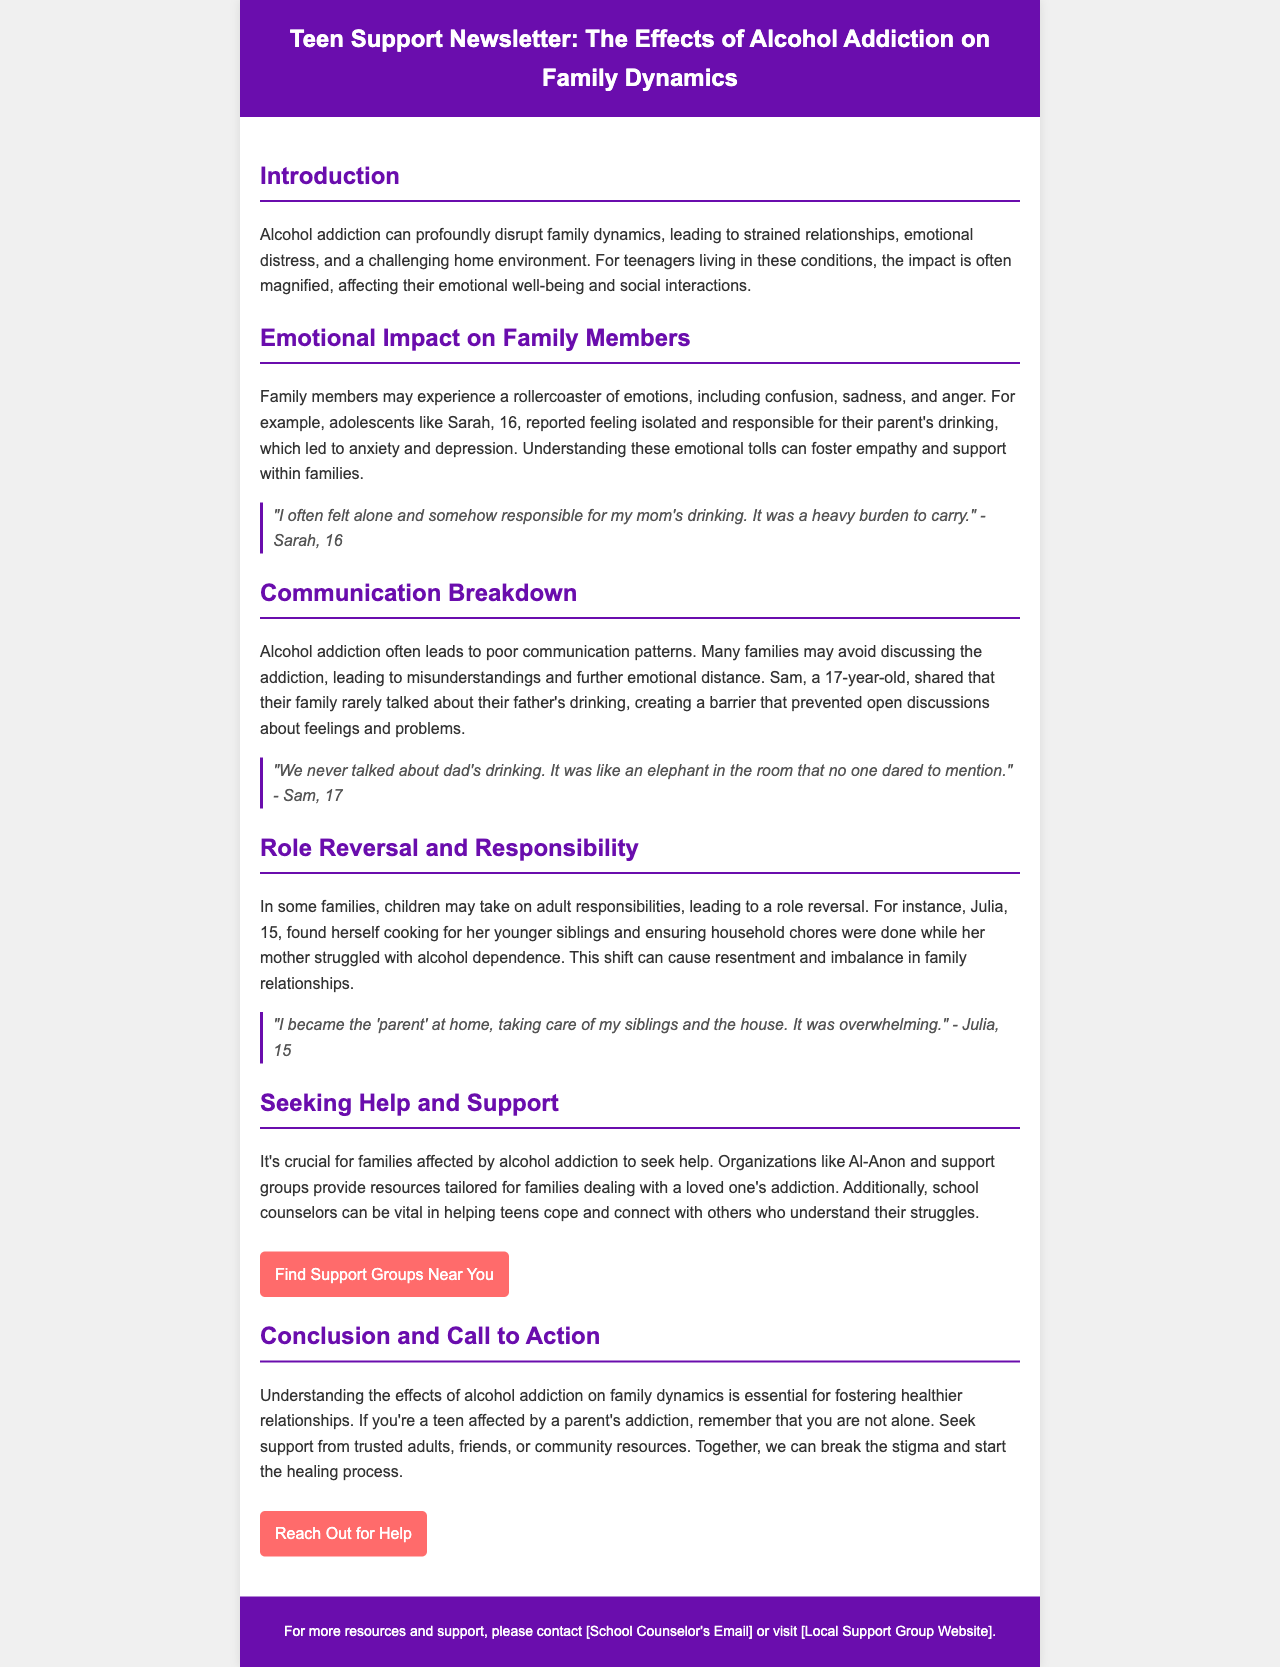What is the title of the newsletter? The title of the newsletter is mentioned at the top of the document.
Answer: Teen Support Newsletter: The Effects of Alcohol Addiction on Family Dynamics Who shared their feelings of being alone and responsible for their mom's drinking? The document includes a quote from a teenager expressing such feelings.
Answer: Sarah, 16 What age is Julia, who discusses taking care of her siblings? Julia is identified with her age in the section discussing role reversal.
Answer: 15 Name one organization that provides resources for families affected by alcohol addiction. The document lists organizations that can help families, including Al-Anon.
Answer: Al-Anon What is one emotional effect on family members described in the newsletter? The newsletter outlines several emotional effects that family members may experience due to addiction.
Answer: Confusion What communication issue is highlighted in the family's discussion about addiction? The document describes an observation related to communication within families.
Answer: Poor communication patterns What type of responsibilities did children take on in families affected by alcohol addiction? The newsletter discusses the shift in responsibilities within families affected by addiction.
Answer: Adult responsibilities What is encouraged for teens affected by a parent's addiction? The conclusion of the newsletter includes recommendations for teens in this situation.
Answer: Seek support What does the document suggest as a crucial action for families impacted by alcohol addiction? The content emphasizes the importance of seeking help for families facing addiction.
Answer: Seek help 